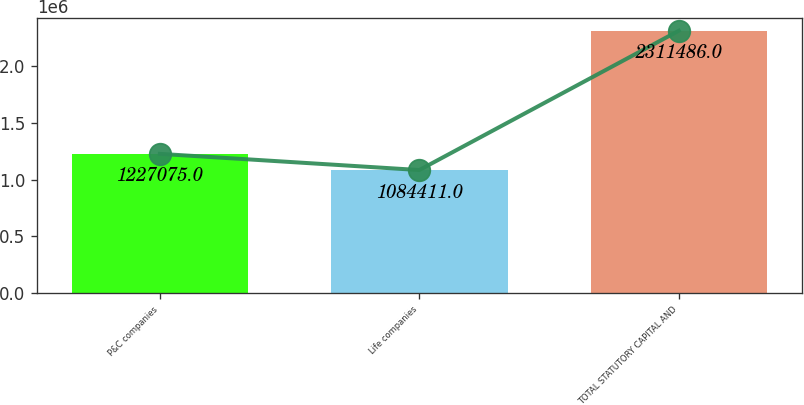<chart> <loc_0><loc_0><loc_500><loc_500><bar_chart><fcel>P&C companies<fcel>Life companies<fcel>TOTAL STATUTORY CAPITAL AND<nl><fcel>1.22708e+06<fcel>1.08441e+06<fcel>2.31149e+06<nl></chart> 